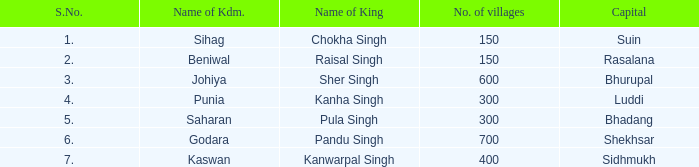Which kingdom has Suin as its capital? Sihag. 